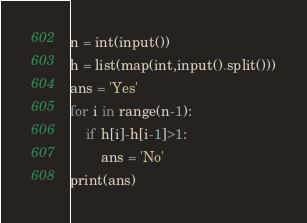<code> <loc_0><loc_0><loc_500><loc_500><_Python_>n = int(input())
h = list(map(int,input().split()))
ans = 'Yes'
for i in range(n-1):
    if h[i]-h[i-1]>1:
        ans = 'No'
print(ans)</code> 